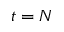Convert formula to latex. <formula><loc_0><loc_0><loc_500><loc_500>t = N</formula> 